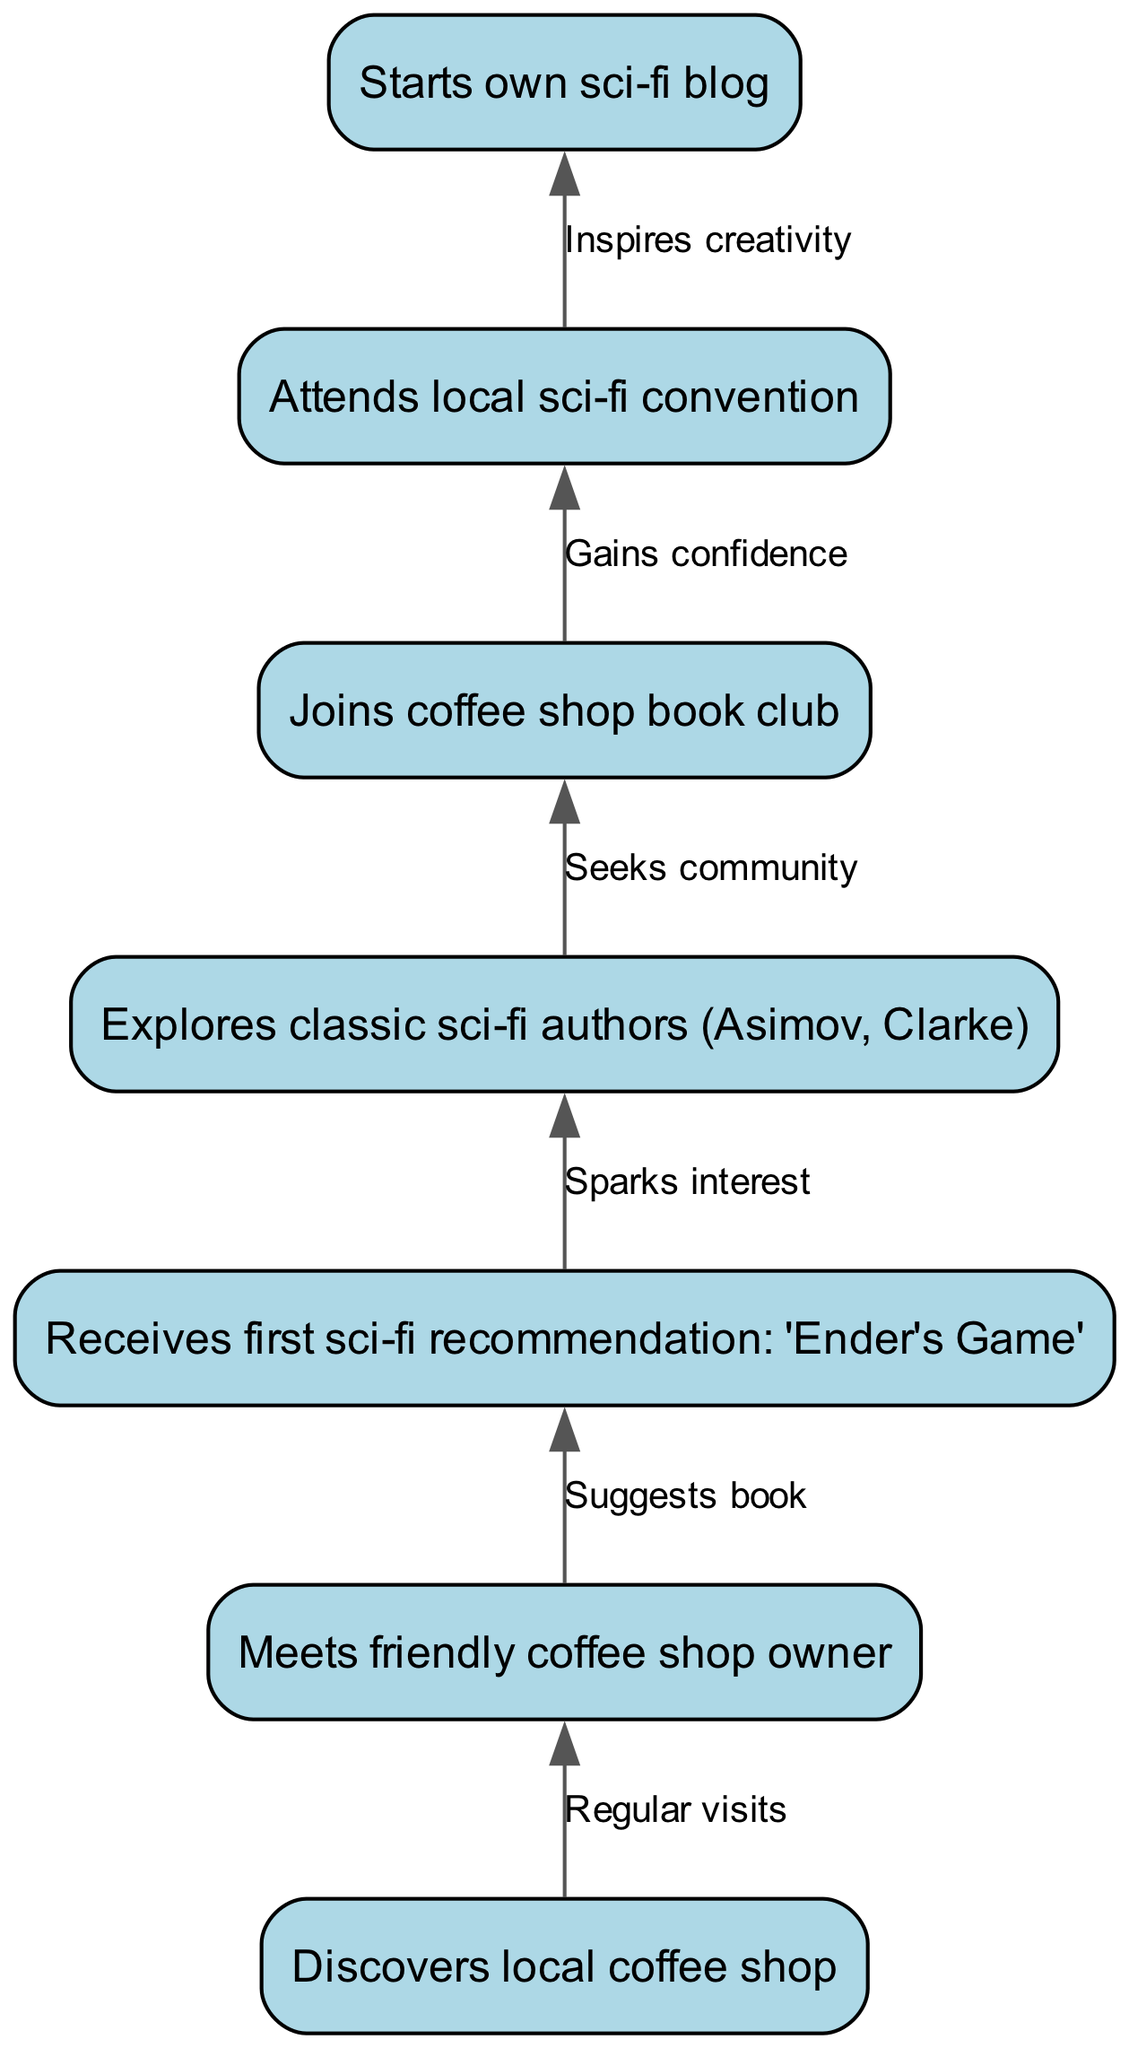What is the first milestone in the teenager's journey? The first node in the diagram is "Discovers local coffee shop," indicating that this event is the starting point of the journey.
Answer: Discovers local coffee shop How many nodes are there in the diagram? By counting the individual entries in the nodes section, we find there are seven unique milestones or events in the teenager's journey.
Answer: Seven What book does the coffee shop owner recommend first? The arrow from node 2 to node 3 indicates a direct relationship where the coffee shop owner suggests the specific book "Ender's Game."
Answer: Ender's Game What do the classic sci-fi authors lead to? The edge from node 3 to node 4 shows that "Ender's Game" sparks interest, leading the teenager to explore authors like Asimov and Clarke.
Answer: Explore classic sci-fi authors (Asimov, Clarke) What event gives the teenager a sense of community? The edge from node 4 to node 5 indicates that the exploration of classic authors prompts the teenager to join a coffee shop book club, signifying a search for community.
Answer: Joins coffee shop book club What inspires the teenager's creativity? The link from node 6 to node 7 indicates that attending the local sci-fi convention plays a crucial role in motivating the teenager to start their own sci-fi blog, which is a creative outlet.
Answer: Inspires creativity What is the last milestone in the journey? The last node in the diagram is "Starts own sci-fi blog," which indicates that this is the final step in the evolution of the teenager's journey into becoming a sci-fi enthusiast.
Answer: Starts own sci-fi blog Which activity boosts the teenager's confidence? The edge from node 5 to node 6 shows that after joining the coffee shop book club, the teenager attends a local sci-fi convention, marking a boost in their confidence.
Answer: Gains confidence What connects the coffee shop visits to meeting the owner? The connection between node 1 and node 2, represented by the text "Regular visits," indicates that the teenager's consistent attendance at the coffee shop leads them to meet the friendly owner.
Answer: Regular visits 